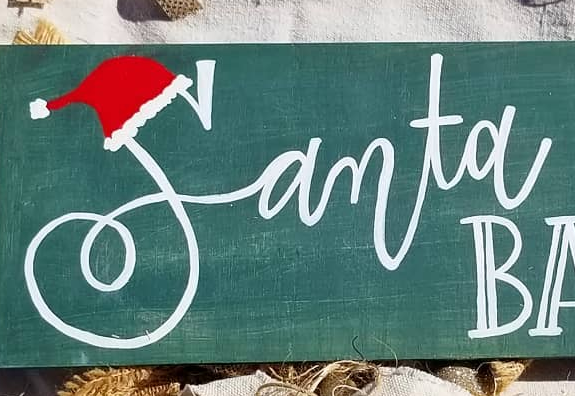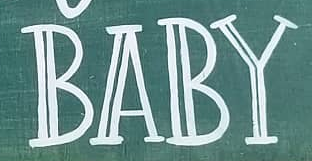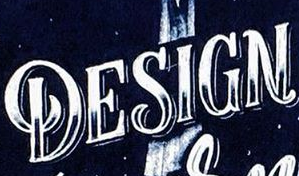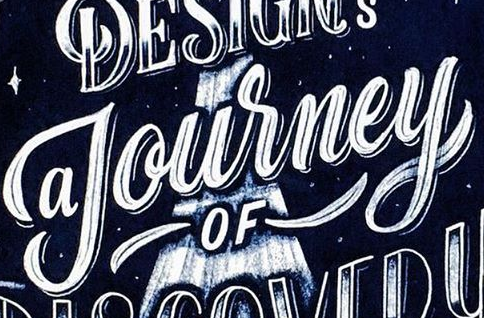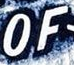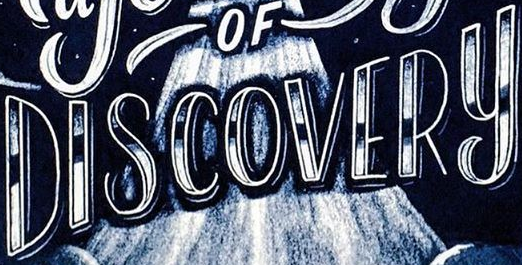Transcribe the words shown in these images in order, separated by a semicolon. Samta; BABY; DESIGN; Journey; OF; DISCOVERY 